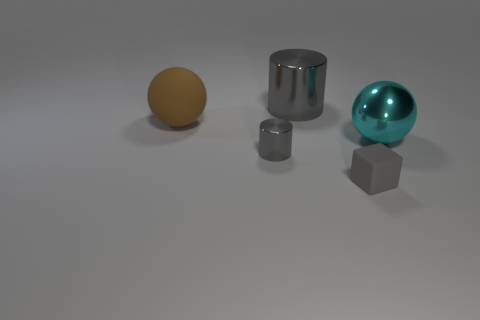Is the color of the cube the same as the big metallic cylinder?
Your answer should be compact. Yes. There is a shiny ball that is the same size as the brown thing; what color is it?
Your response must be concise. Cyan. How many blocks are in front of the large brown rubber sphere?
Offer a very short reply. 1. Are there any small cylinders that have the same material as the cyan thing?
Keep it short and to the point. Yes. The large thing that is the same color as the small block is what shape?
Your answer should be compact. Cylinder. The large ball that is to the right of the big gray metal object is what color?
Give a very brief answer. Cyan. Is the number of big cyan metallic spheres on the left side of the tiny gray cube the same as the number of gray matte cubes that are behind the large shiny sphere?
Provide a succinct answer. Yes. The gray cylinder that is to the right of the small thing that is left of the block is made of what material?
Provide a short and direct response. Metal. How many objects are either big green metal cylinders or cylinders behind the large brown sphere?
Your answer should be very brief. 1. What is the size of the cyan ball that is made of the same material as the big cylinder?
Give a very brief answer. Large. 